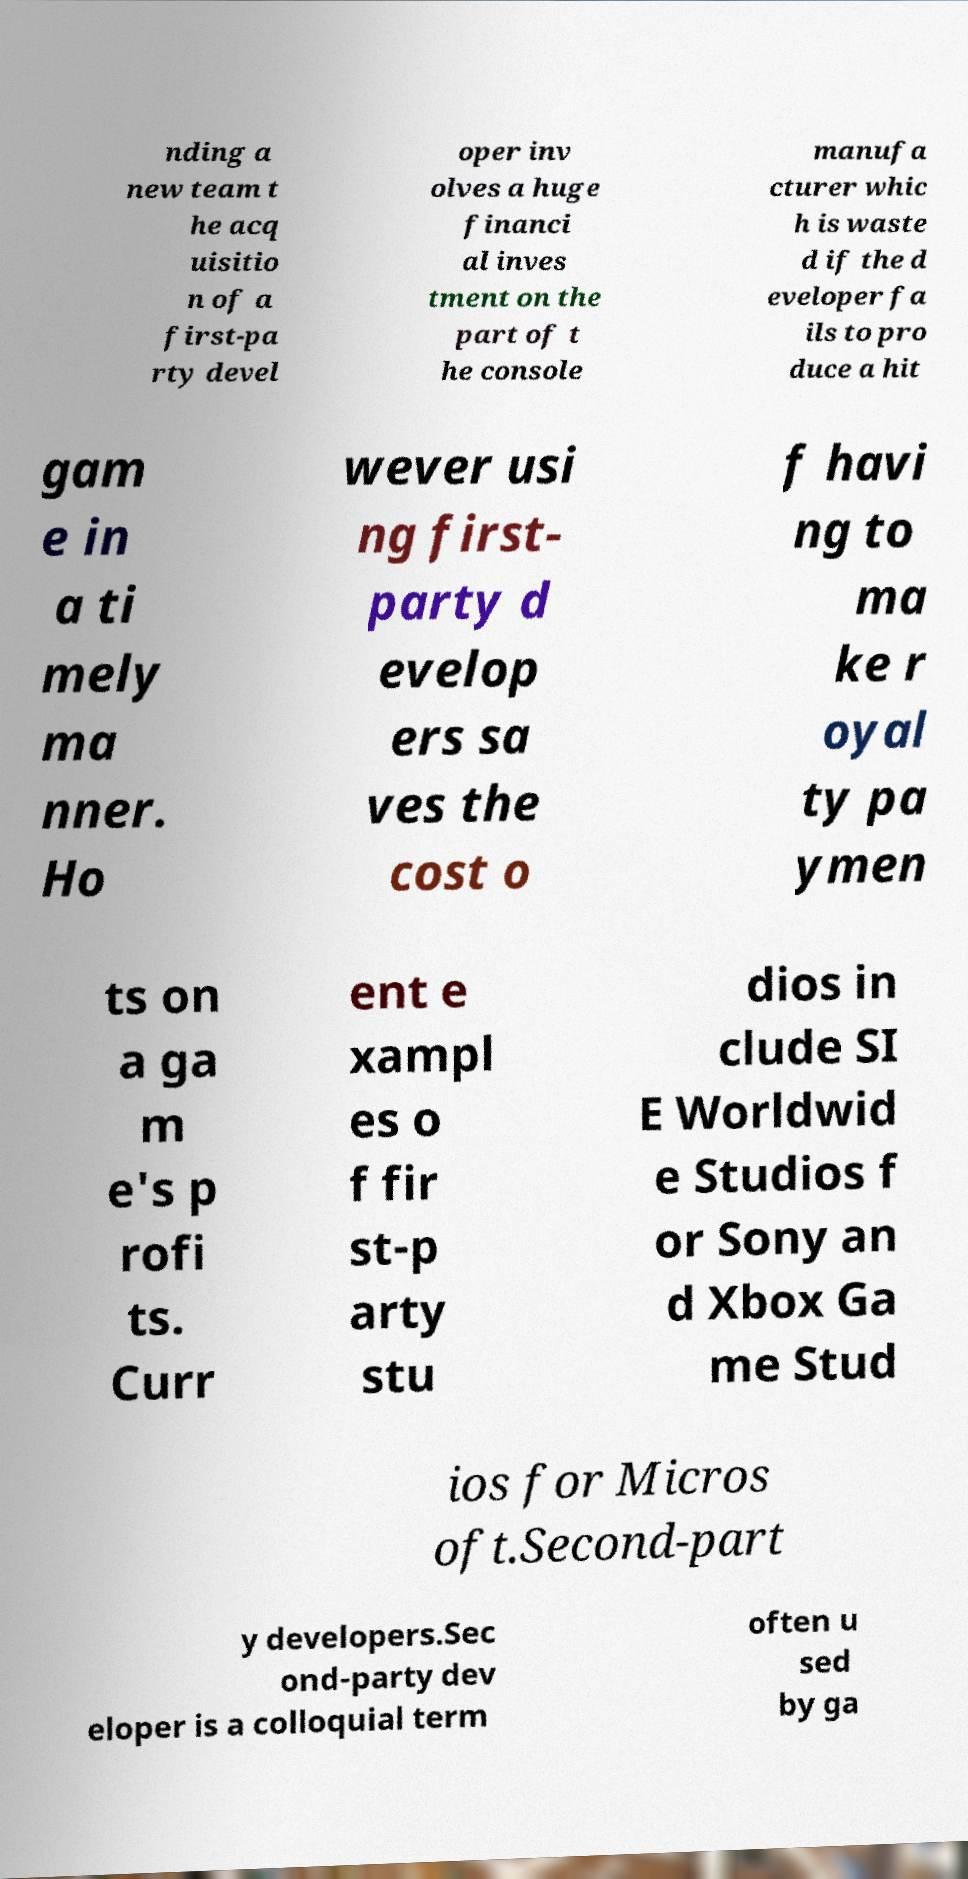I need the written content from this picture converted into text. Can you do that? nding a new team t he acq uisitio n of a first-pa rty devel oper inv olves a huge financi al inves tment on the part of t he console manufa cturer whic h is waste d if the d eveloper fa ils to pro duce a hit gam e in a ti mely ma nner. Ho wever usi ng first- party d evelop ers sa ves the cost o f havi ng to ma ke r oyal ty pa ymen ts on a ga m e's p rofi ts. Curr ent e xampl es o f fir st-p arty stu dios in clude SI E Worldwid e Studios f or Sony an d Xbox Ga me Stud ios for Micros oft.Second-part y developers.Sec ond-party dev eloper is a colloquial term often u sed by ga 